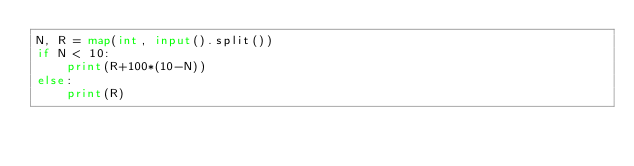Convert code to text. <code><loc_0><loc_0><loc_500><loc_500><_Python_>N, R = map(int, input().split())
if N < 10:
    print(R+100*(10-N))
else:
    print(R)
</code> 